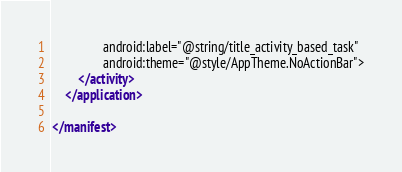Convert code to text. <code><loc_0><loc_0><loc_500><loc_500><_XML_>                android:label="@string/title_activity_based_task"
                android:theme="@style/AppTheme.NoActionBar">
        </activity>
    </application>

</manifest></code> 